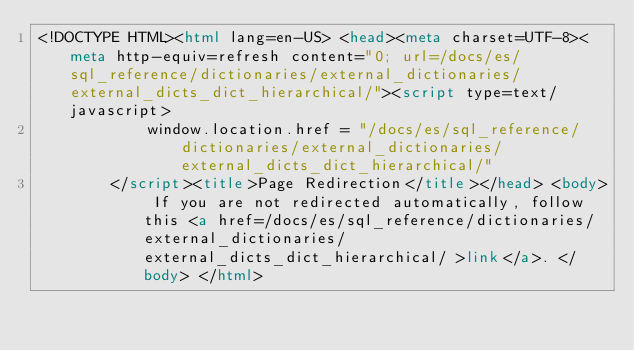Convert code to text. <code><loc_0><loc_0><loc_500><loc_500><_HTML_><!DOCTYPE HTML><html lang=en-US> <head><meta charset=UTF-8><meta http-equiv=refresh content="0; url=/docs/es/sql_reference/dictionaries/external_dictionaries/external_dicts_dict_hierarchical/"><script type=text/javascript>
            window.location.href = "/docs/es/sql_reference/dictionaries/external_dictionaries/external_dicts_dict_hierarchical/"
        </script><title>Page Redirection</title></head> <body> If you are not redirected automatically, follow this <a href=/docs/es/sql_reference/dictionaries/external_dictionaries/external_dicts_dict_hierarchical/ >link</a>. </body> </html></code> 